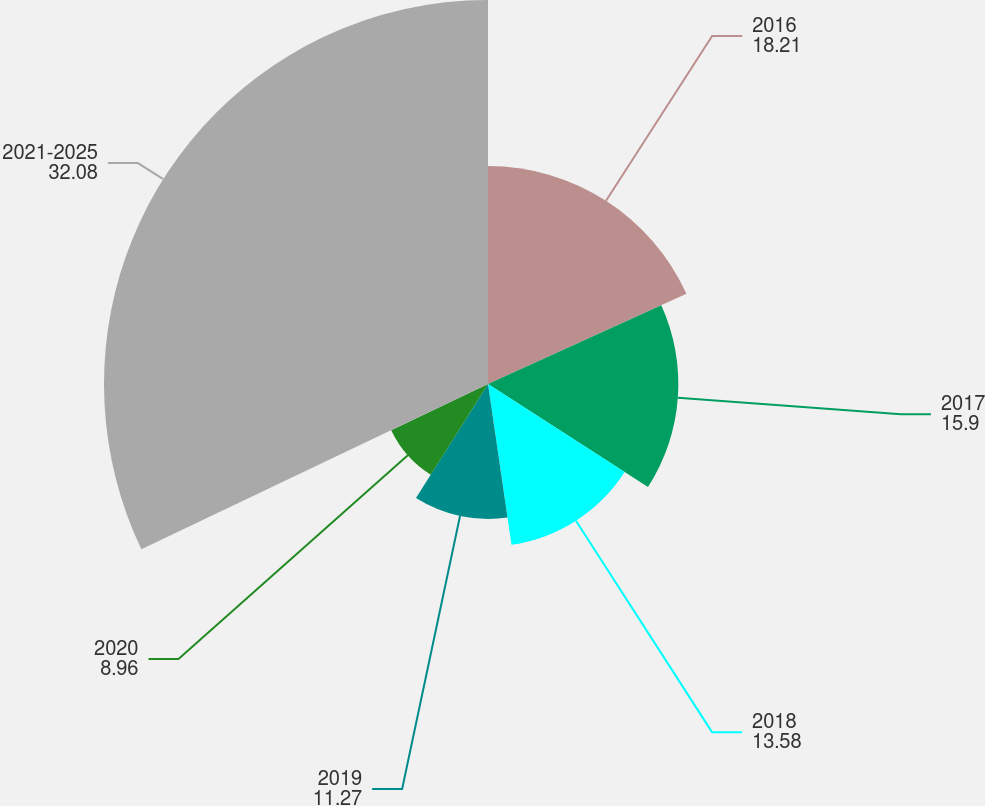Convert chart. <chart><loc_0><loc_0><loc_500><loc_500><pie_chart><fcel>2016<fcel>2017<fcel>2018<fcel>2019<fcel>2020<fcel>2021-2025<nl><fcel>18.21%<fcel>15.9%<fcel>13.58%<fcel>11.27%<fcel>8.96%<fcel>32.08%<nl></chart> 